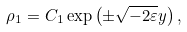Convert formula to latex. <formula><loc_0><loc_0><loc_500><loc_500>\rho _ { 1 } = C _ { 1 } \exp \left ( \pm \sqrt { - 2 \varepsilon } y \right ) ,</formula> 